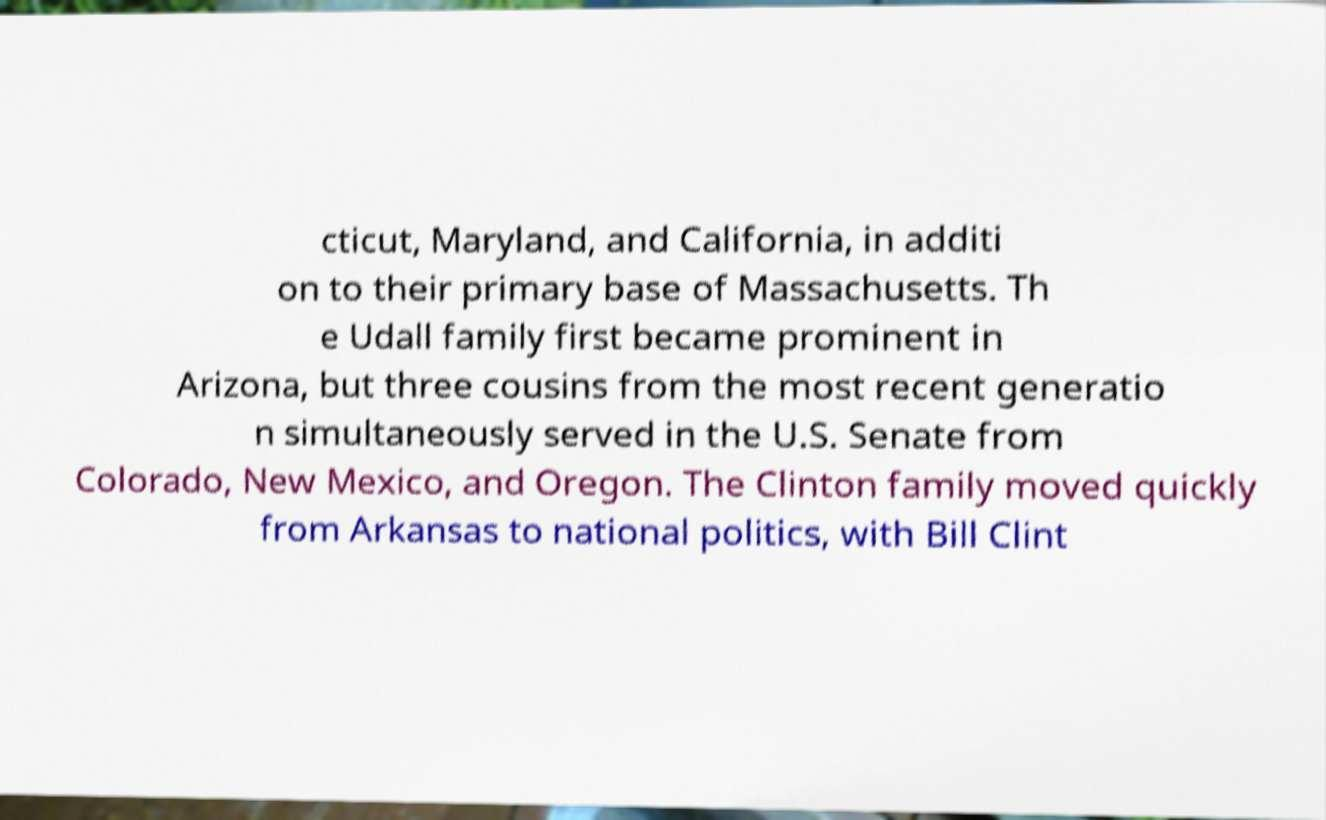Can you read and provide the text displayed in the image?This photo seems to have some interesting text. Can you extract and type it out for me? cticut, Maryland, and California, in additi on to their primary base of Massachusetts. Th e Udall family first became prominent in Arizona, but three cousins from the most recent generatio n simultaneously served in the U.S. Senate from Colorado, New Mexico, and Oregon. The Clinton family moved quickly from Arkansas to national politics, with Bill Clint 